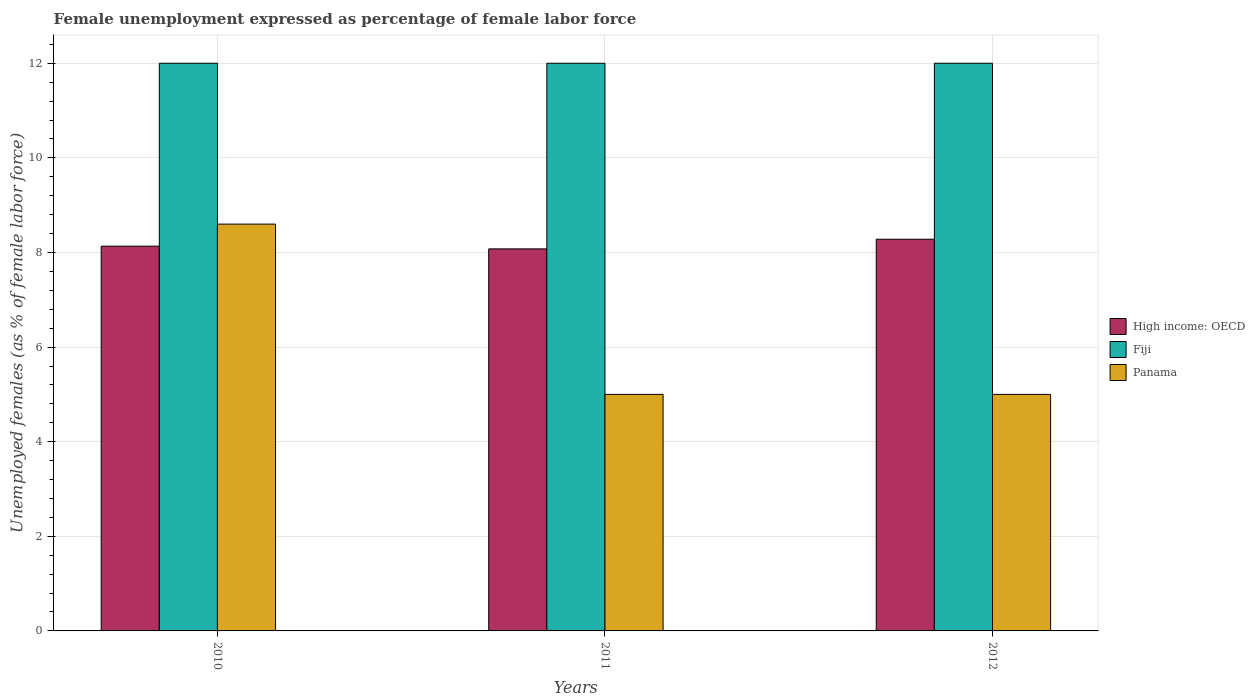Are the number of bars on each tick of the X-axis equal?
Keep it short and to the point. Yes. How many bars are there on the 2nd tick from the right?
Provide a short and direct response. 3. Across all years, what is the maximum unemployment in females in in Panama?
Your response must be concise. 8.6. What is the total unemployment in females in in High income: OECD in the graph?
Offer a terse response. 24.49. What is the difference between the unemployment in females in in High income: OECD in 2011 and that in 2012?
Offer a very short reply. -0.2. What is the difference between the unemployment in females in in Fiji in 2010 and the unemployment in females in in High income: OECD in 2012?
Your response must be concise. 3.72. What is the average unemployment in females in in Panama per year?
Ensure brevity in your answer.  6.2. In the year 2010, what is the difference between the unemployment in females in in Panama and unemployment in females in in Fiji?
Make the answer very short. -3.4. In how many years, is the unemployment in females in in High income: OECD greater than 0.4 %?
Provide a succinct answer. 3. What is the ratio of the unemployment in females in in Panama in 2010 to that in 2012?
Your response must be concise. 1.72. Is the unemployment in females in in Fiji in 2011 less than that in 2012?
Ensure brevity in your answer.  No. What is the difference between the highest and the second highest unemployment in females in in High income: OECD?
Your response must be concise. 0.15. What is the difference between the highest and the lowest unemployment in females in in Panama?
Ensure brevity in your answer.  3.6. In how many years, is the unemployment in females in in Fiji greater than the average unemployment in females in in Fiji taken over all years?
Offer a very short reply. 0. Is the sum of the unemployment in females in in Panama in 2010 and 2012 greater than the maximum unemployment in females in in Fiji across all years?
Provide a succinct answer. Yes. What does the 2nd bar from the left in 2011 represents?
Offer a very short reply. Fiji. What does the 3rd bar from the right in 2011 represents?
Offer a terse response. High income: OECD. What is the difference between two consecutive major ticks on the Y-axis?
Your answer should be compact. 2. How many legend labels are there?
Make the answer very short. 3. How are the legend labels stacked?
Give a very brief answer. Vertical. What is the title of the graph?
Offer a terse response. Female unemployment expressed as percentage of female labor force. What is the label or title of the Y-axis?
Provide a succinct answer. Unemployed females (as % of female labor force). What is the Unemployed females (as % of female labor force) in High income: OECD in 2010?
Your answer should be very brief. 8.13. What is the Unemployed females (as % of female labor force) in Panama in 2010?
Provide a succinct answer. 8.6. What is the Unemployed females (as % of female labor force) in High income: OECD in 2011?
Keep it short and to the point. 8.08. What is the Unemployed females (as % of female labor force) in Panama in 2011?
Your response must be concise. 5. What is the Unemployed females (as % of female labor force) of High income: OECD in 2012?
Provide a short and direct response. 8.28. What is the Unemployed females (as % of female labor force) of Fiji in 2012?
Your answer should be very brief. 12. What is the Unemployed females (as % of female labor force) in Panama in 2012?
Your answer should be compact. 5. Across all years, what is the maximum Unemployed females (as % of female labor force) in High income: OECD?
Offer a terse response. 8.28. Across all years, what is the maximum Unemployed females (as % of female labor force) in Fiji?
Keep it short and to the point. 12. Across all years, what is the maximum Unemployed females (as % of female labor force) in Panama?
Your answer should be compact. 8.6. Across all years, what is the minimum Unemployed females (as % of female labor force) of High income: OECD?
Give a very brief answer. 8.08. Across all years, what is the minimum Unemployed females (as % of female labor force) of Panama?
Offer a very short reply. 5. What is the total Unemployed females (as % of female labor force) in High income: OECD in the graph?
Provide a short and direct response. 24.49. What is the total Unemployed females (as % of female labor force) in Fiji in the graph?
Your answer should be compact. 36. What is the difference between the Unemployed females (as % of female labor force) in High income: OECD in 2010 and that in 2011?
Ensure brevity in your answer.  0.06. What is the difference between the Unemployed females (as % of female labor force) of Panama in 2010 and that in 2011?
Your response must be concise. 3.6. What is the difference between the Unemployed females (as % of female labor force) of High income: OECD in 2010 and that in 2012?
Give a very brief answer. -0.15. What is the difference between the Unemployed females (as % of female labor force) of High income: OECD in 2011 and that in 2012?
Offer a very short reply. -0.2. What is the difference between the Unemployed females (as % of female labor force) of Fiji in 2011 and that in 2012?
Keep it short and to the point. 0. What is the difference between the Unemployed females (as % of female labor force) in High income: OECD in 2010 and the Unemployed females (as % of female labor force) in Fiji in 2011?
Make the answer very short. -3.87. What is the difference between the Unemployed females (as % of female labor force) of High income: OECD in 2010 and the Unemployed females (as % of female labor force) of Panama in 2011?
Ensure brevity in your answer.  3.13. What is the difference between the Unemployed females (as % of female labor force) of Fiji in 2010 and the Unemployed females (as % of female labor force) of Panama in 2011?
Give a very brief answer. 7. What is the difference between the Unemployed females (as % of female labor force) of High income: OECD in 2010 and the Unemployed females (as % of female labor force) of Fiji in 2012?
Ensure brevity in your answer.  -3.87. What is the difference between the Unemployed females (as % of female labor force) of High income: OECD in 2010 and the Unemployed females (as % of female labor force) of Panama in 2012?
Your answer should be very brief. 3.13. What is the difference between the Unemployed females (as % of female labor force) of High income: OECD in 2011 and the Unemployed females (as % of female labor force) of Fiji in 2012?
Give a very brief answer. -3.92. What is the difference between the Unemployed females (as % of female labor force) in High income: OECD in 2011 and the Unemployed females (as % of female labor force) in Panama in 2012?
Offer a terse response. 3.08. What is the difference between the Unemployed females (as % of female labor force) in Fiji in 2011 and the Unemployed females (as % of female labor force) in Panama in 2012?
Give a very brief answer. 7. What is the average Unemployed females (as % of female labor force) in High income: OECD per year?
Your answer should be very brief. 8.16. What is the average Unemployed females (as % of female labor force) of Fiji per year?
Your answer should be compact. 12. In the year 2010, what is the difference between the Unemployed females (as % of female labor force) of High income: OECD and Unemployed females (as % of female labor force) of Fiji?
Offer a terse response. -3.87. In the year 2010, what is the difference between the Unemployed females (as % of female labor force) in High income: OECD and Unemployed females (as % of female labor force) in Panama?
Provide a succinct answer. -0.47. In the year 2011, what is the difference between the Unemployed females (as % of female labor force) of High income: OECD and Unemployed females (as % of female labor force) of Fiji?
Give a very brief answer. -3.92. In the year 2011, what is the difference between the Unemployed females (as % of female labor force) in High income: OECD and Unemployed females (as % of female labor force) in Panama?
Ensure brevity in your answer.  3.08. In the year 2011, what is the difference between the Unemployed females (as % of female labor force) in Fiji and Unemployed females (as % of female labor force) in Panama?
Provide a short and direct response. 7. In the year 2012, what is the difference between the Unemployed females (as % of female labor force) of High income: OECD and Unemployed females (as % of female labor force) of Fiji?
Ensure brevity in your answer.  -3.72. In the year 2012, what is the difference between the Unemployed females (as % of female labor force) in High income: OECD and Unemployed females (as % of female labor force) in Panama?
Provide a succinct answer. 3.28. In the year 2012, what is the difference between the Unemployed females (as % of female labor force) in Fiji and Unemployed females (as % of female labor force) in Panama?
Ensure brevity in your answer.  7. What is the ratio of the Unemployed females (as % of female labor force) of High income: OECD in 2010 to that in 2011?
Provide a succinct answer. 1.01. What is the ratio of the Unemployed females (as % of female labor force) of Panama in 2010 to that in 2011?
Your answer should be very brief. 1.72. What is the ratio of the Unemployed females (as % of female labor force) in High income: OECD in 2010 to that in 2012?
Provide a short and direct response. 0.98. What is the ratio of the Unemployed females (as % of female labor force) of Panama in 2010 to that in 2012?
Offer a terse response. 1.72. What is the ratio of the Unemployed females (as % of female labor force) of High income: OECD in 2011 to that in 2012?
Provide a succinct answer. 0.98. What is the ratio of the Unemployed females (as % of female labor force) in Panama in 2011 to that in 2012?
Offer a very short reply. 1. What is the difference between the highest and the second highest Unemployed females (as % of female labor force) in High income: OECD?
Make the answer very short. 0.15. What is the difference between the highest and the second highest Unemployed females (as % of female labor force) in Fiji?
Your answer should be compact. 0. What is the difference between the highest and the lowest Unemployed females (as % of female labor force) of High income: OECD?
Give a very brief answer. 0.2. What is the difference between the highest and the lowest Unemployed females (as % of female labor force) of Panama?
Your answer should be compact. 3.6. 